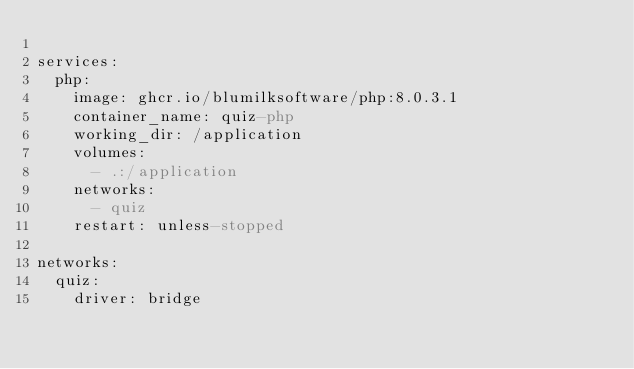<code> <loc_0><loc_0><loc_500><loc_500><_YAML_>
services:
  php:
    image: ghcr.io/blumilksoftware/php:8.0.3.1
    container_name: quiz-php
    working_dir: /application
    volumes:
      - .:/application
    networks:
      - quiz
    restart: unless-stopped

networks:
  quiz:
    driver: bridge
</code> 